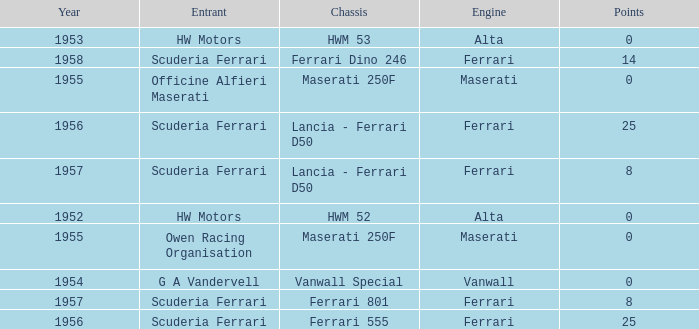What is the entrant earlier than 1956 with a Vanwall Special chassis? G A Vandervell. 